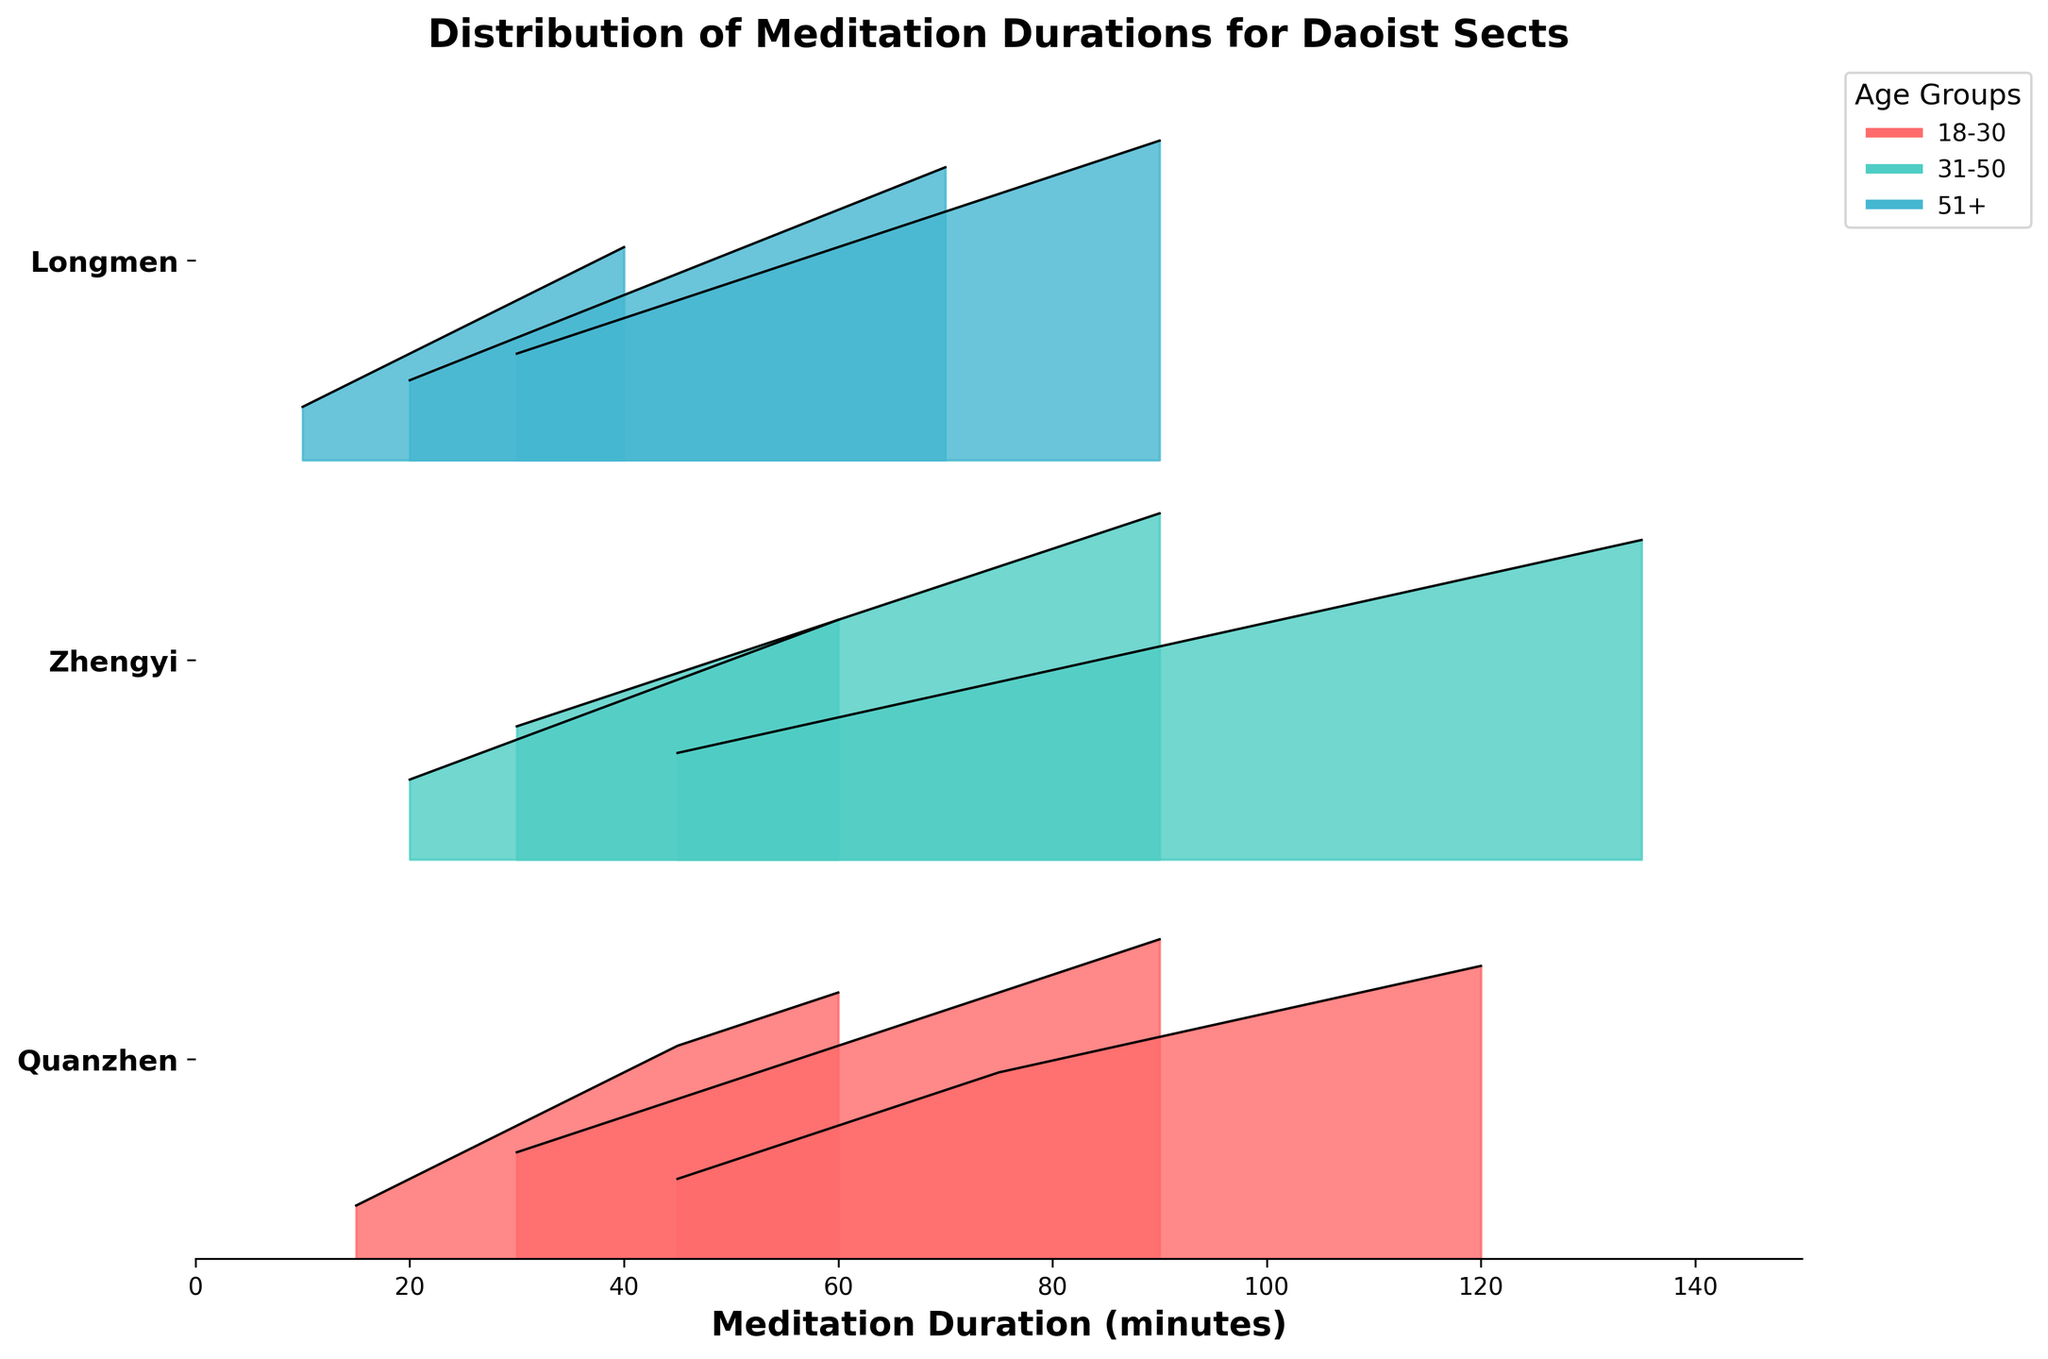what is the title of the plot? The title of the plot is typically displayed at the top of the figure and provides a summary of what the plot represents. Here, it reads "Distribution of Meditation Durations for Daoist Sects".
Answer: Distribution of Meditation Durations for Daoist Sects What does the x-axis represent in this plot? In the given figure, the x-axis is labeled as "Meditation Duration (minutes)", suggesting it shows the duration of meditation in minutes.
Answer: Meditation Duration (minutes) Which Daoist sect has the highest density for the 51+ age group? By examining the plot, we can see that the Quanzhen sect's density for the 51+ age group peaks at 0.11, whereas the Zhengyi and Longmen sects' peaks are at 0.12. Therefore, Zhengyi and Longmen both have the highest density for the 51+ age group.
Answer: Zhengyi and Longmen For which age group does the Longmen sect have the highest density? Looking at the ridgeline plot for the Longmen sect, we can see that the density peaks for each age group: 0.08 for 18-30, 0.11 for 31-50, and 0.12 for 51+. The highest peak is for the 51+ age group.
Answer: 51+ What is the duration range for the Quanzhen sect in the 31-50 age group? By checking the boundaries for the Quanzhen sect's 31-50 age group, we notice durations starting from 30 minutes and going up to 90 minutes.
Answer: 30-90 minutes Which sect has a broader range of meditation durations in the 18-30 age group? By comparing the durations across the sects for the 18-30 age group: Quanzhen (15-60 minutes), Zhengyi (20-60 minutes), and Longmen (10-40 minutes), the Quanzhen sect displays the broadest range of meditation durations.
Answer: Quanzhen In the 31-50 age group, which Daoist sect shows the highest peak density? Observing the peaks within the 31-50 age group, Zhengyi sect has the highest peak with a density of 0.13, higher than Quanzhen's peak of 0.12 and Longmen's peak of 0.11.
Answer: Zhengyi Compare the highest meditation duration density for the 51+ age group between Quanzhen and Zhengyi sects. The highest density for Quanzhen is 0.11 at 120 minutes, and for Zhengyi, it's 0.12 at 135 minutes. By comparing these, Zhengyi has the higher peak density.
Answer: Zhengyi What is the peak density for the longest meditation duration recorded in the Longmen sect's 51+ age group? In the Longmen sect's 51+ age group, the highest density for the longest duration (90 minutes) is 0.12.
Answer: 0.12 Which age group has the lowest density peak in the Quanzhen sect? For the Quanzhen sect, the density peaks for different age groups are 0.10 (18-30), 0.12 (31-50), and 0.11 (51+). The lowest peak density is in the 18-30 age group at 0.10.
Answer: 18-30 